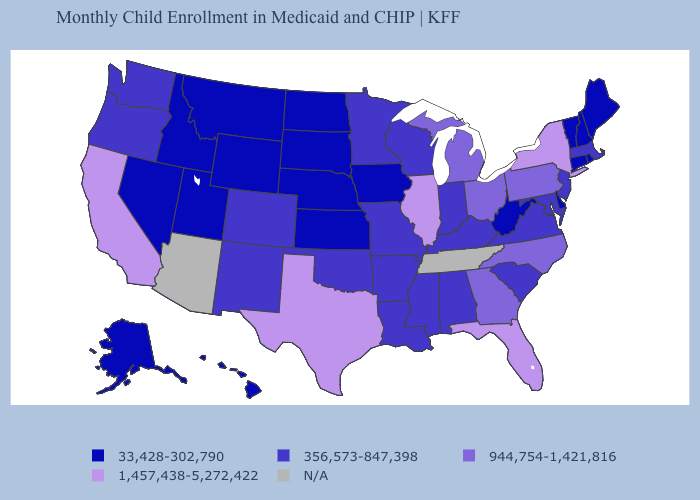Name the states that have a value in the range 1,457,438-5,272,422?
Short answer required. California, Florida, Illinois, New York, Texas. Which states have the lowest value in the MidWest?
Be succinct. Iowa, Kansas, Nebraska, North Dakota, South Dakota. Among the states that border North Carolina , which have the highest value?
Short answer required. Georgia. Name the states that have a value in the range 33,428-302,790?
Concise answer only. Alaska, Connecticut, Delaware, Hawaii, Idaho, Iowa, Kansas, Maine, Montana, Nebraska, Nevada, New Hampshire, North Dakota, Rhode Island, South Dakota, Utah, Vermont, West Virginia, Wyoming. What is the lowest value in the South?
Write a very short answer. 33,428-302,790. Among the states that border Virginia , which have the highest value?
Quick response, please. North Carolina. What is the value of Connecticut?
Concise answer only. 33,428-302,790. What is the highest value in states that border Florida?
Concise answer only. 944,754-1,421,816. Name the states that have a value in the range 33,428-302,790?
Concise answer only. Alaska, Connecticut, Delaware, Hawaii, Idaho, Iowa, Kansas, Maine, Montana, Nebraska, Nevada, New Hampshire, North Dakota, Rhode Island, South Dakota, Utah, Vermont, West Virginia, Wyoming. Among the states that border Washington , does Idaho have the lowest value?
Give a very brief answer. Yes. Among the states that border Montana , which have the lowest value?
Short answer required. Idaho, North Dakota, South Dakota, Wyoming. Does California have the highest value in the USA?
Write a very short answer. Yes. What is the value of Connecticut?
Keep it brief. 33,428-302,790. Name the states that have a value in the range 33,428-302,790?
Quick response, please. Alaska, Connecticut, Delaware, Hawaii, Idaho, Iowa, Kansas, Maine, Montana, Nebraska, Nevada, New Hampshire, North Dakota, Rhode Island, South Dakota, Utah, Vermont, West Virginia, Wyoming. 